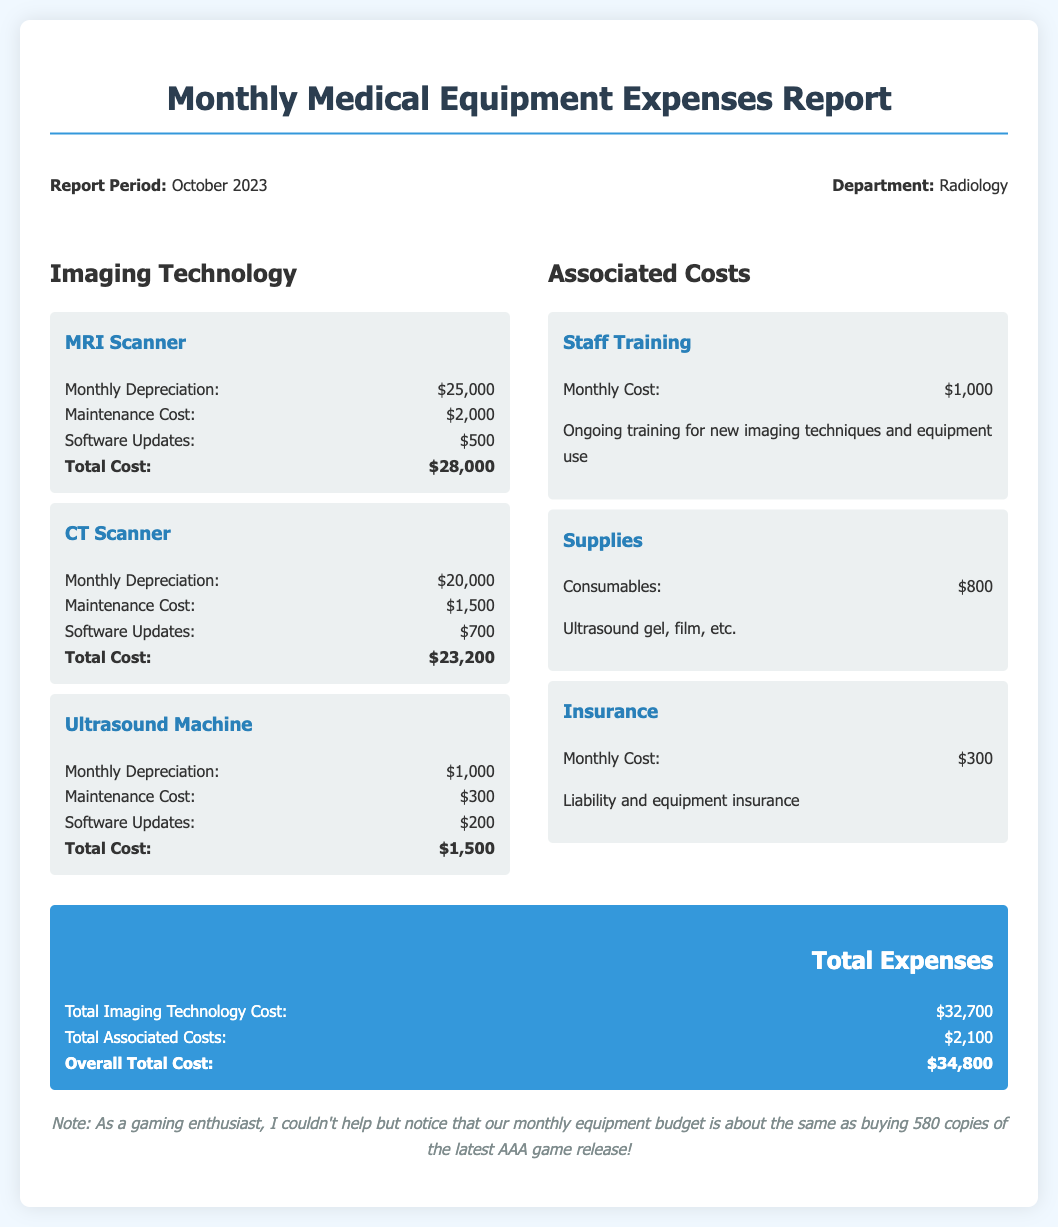What is the report period? The report period is stated at the top of the document as October 2023.
Answer: October 2023 What is the total cost for the MRI Scanner? The total cost for the MRI Scanner is detailed in the cost section, which sums to $28,000.
Answer: $28,000 What is the maintenance cost for the CT Scanner? The maintenance cost for the CT Scanner is found in the cost details, which is $1,500.
Answer: $1,500 What are the supplies costs? The cost of consumables listed under supplies amounts to $800.
Answer: $800 What is the overall total cost? The overall total cost is calculated from the total imaging technology cost and the total associated costs, which is $34,800.
Answer: $34,800 What is the total imaging technology cost? The total imaging technology cost is the sum of costs for all imaging technologies, totaling $32,700.
Answer: $32,700 What additional cost is associated with staff training? The cost for staff training is listed in the associated costs section, which is $1,000.
Answer: $1,000 What is included in the software updates for the MRI Scanner? The document details software updates for the MRI Scanner with a cost of $500.
Answer: $500 How many copies of the latest AAA game could the monthly equipment budget purchase? The note at the bottom suggests that the budget could purchase about 580 copies of the game.
Answer: 580 